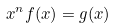<formula> <loc_0><loc_0><loc_500><loc_500>x ^ { n } f ( x ) = g ( x )</formula> 